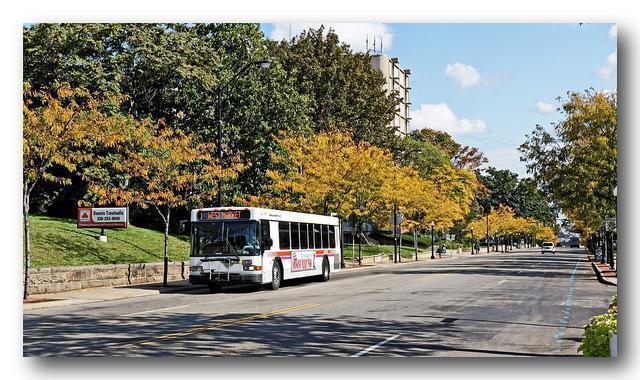What color is the line on the floor that is all the way to the right?
Pick the right solution, then justify: 'Answer: answer
Rationale: rationale.'
Options: Blue, purple, orange, black. Answer: blue.
Rationale: The line on the right is blue. 